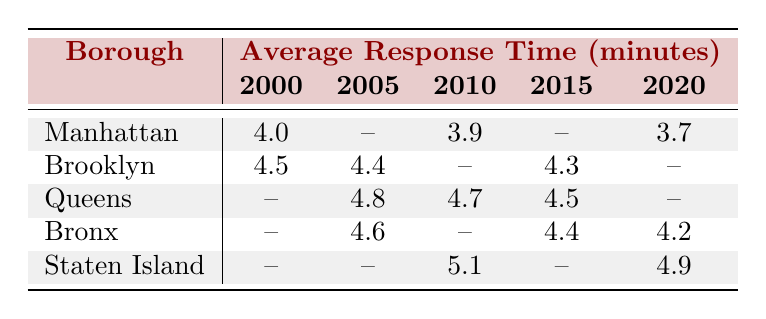What was the average response time for Manhattan in 2000? The average response time for Manhattan in 2000 is directly available in the table as 4.0 minutes.
Answer: 4.0 What is the average response time for Brooklyn in 2015? The table shows that the average response time for Brooklyn in 2015 is 4.3 minutes, which is explicitly listed in the row for Brooklyn under the 2015 column.
Answer: 4.3 Did the Bronx have a lower average response time than Queens in 2020? The Bronx had an average response time of 4.2 minutes in 2020, while Queens has a missing entry for 2020; therefore, we cannot definitively compare their response times for that year.
Answer: No Which borough had the highest average response time in 2010? In 2010, the table shows that Staten Island has an average response time of 5.1 minutes, which is higher than Manhattan (3.9), Brooklyn (not available), and the Bronx (not available). Queens also has an entry for 4.7 minutes. Therefore, Staten Island had the highest response time in the 2010 data.
Answer: Staten Island What is the difference in the average response time between Bronx in 2015 and Bronx in 2020? The average response time for Bronx in 2015 is 4.4 minutes and in 2020 is 4.2 minutes. To find the difference, we subtract 4.2 from 4.4, giving us 0.2 minutes.
Answer: 0.2 What was the average response time for all boroughs in 2005? From the table, the available data for 2005 includes Brooklyn (4.4) and Bronx (4.6). There are no other entries for this year. To find the average, we sum these two values: 4.4 + 4.6 = 9.0 and divide by 2 (9.0 / 2), resulting in 4.5 minutes.
Answer: 4.5 Was there a year when no data was recorded for Brooklyn? The table shows data for Brooklyn in 2000, 2005, and 2015, but there is no entry for Brooklyn in 2010 or 2020. Therefore, it indicates that there were years when Brooklyn had no recorded response times.
Answer: Yes What is the trend in average response time for Manhattan from 2000 to 2020? The response times for Manhattan over the years are 4.0 in 2000, 3.9 in 2010 (the only available entry for that decade), and 3.7 in 2020. This shows a decreasing trend in average response times over the years.
Answer: Decreasing trend 